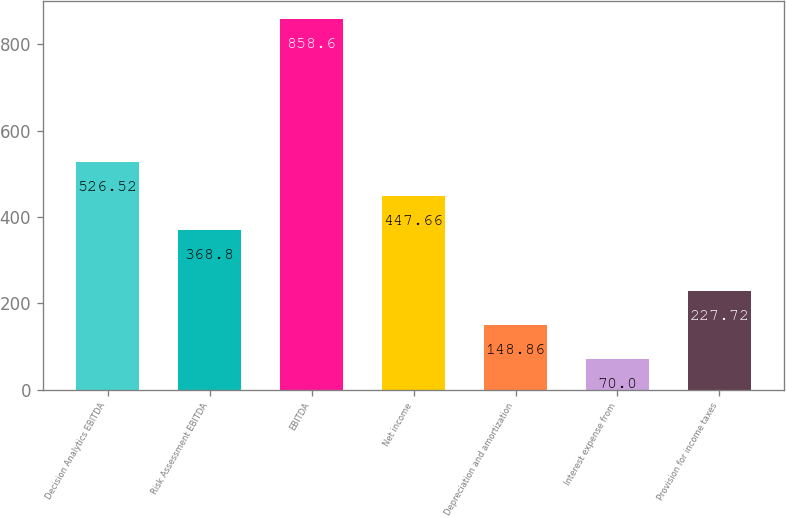Convert chart to OTSL. <chart><loc_0><loc_0><loc_500><loc_500><bar_chart><fcel>Decision Analytics EBITDA<fcel>Risk Assessment EBITDA<fcel>EBITDA<fcel>Net income<fcel>Depreciation and amortization<fcel>Interest expense from<fcel>Provision for income taxes<nl><fcel>526.52<fcel>368.8<fcel>858.6<fcel>447.66<fcel>148.86<fcel>70<fcel>227.72<nl></chart> 